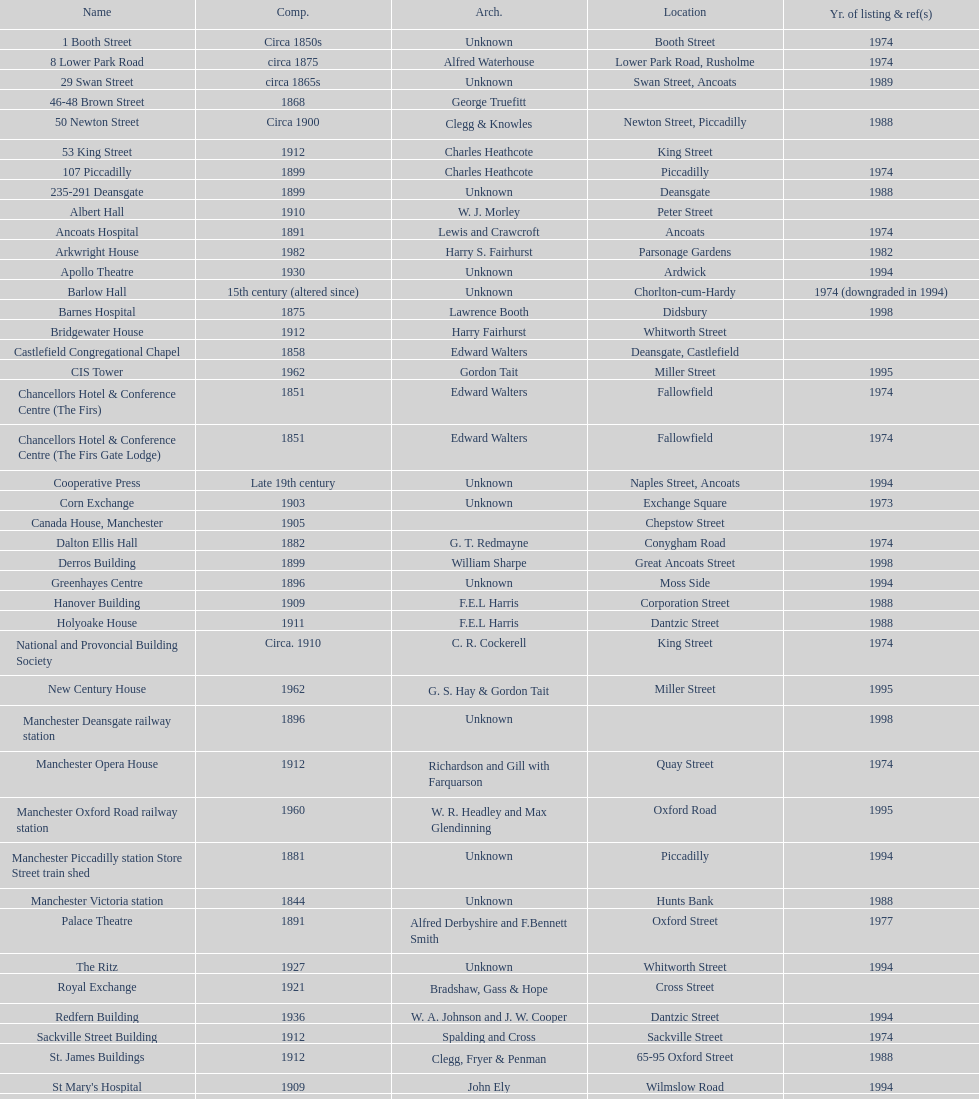Which year has the most buildings listed? 1974. 